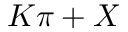<formula> <loc_0><loc_0><loc_500><loc_500>K \pi + X</formula> 